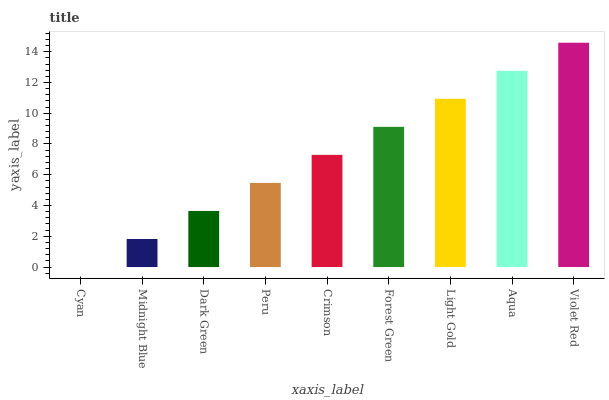Is Cyan the minimum?
Answer yes or no. Yes. Is Violet Red the maximum?
Answer yes or no. Yes. Is Midnight Blue the minimum?
Answer yes or no. No. Is Midnight Blue the maximum?
Answer yes or no. No. Is Midnight Blue greater than Cyan?
Answer yes or no. Yes. Is Cyan less than Midnight Blue?
Answer yes or no. Yes. Is Cyan greater than Midnight Blue?
Answer yes or no. No. Is Midnight Blue less than Cyan?
Answer yes or no. No. Is Crimson the high median?
Answer yes or no. Yes. Is Crimson the low median?
Answer yes or no. Yes. Is Dark Green the high median?
Answer yes or no. No. Is Dark Green the low median?
Answer yes or no. No. 